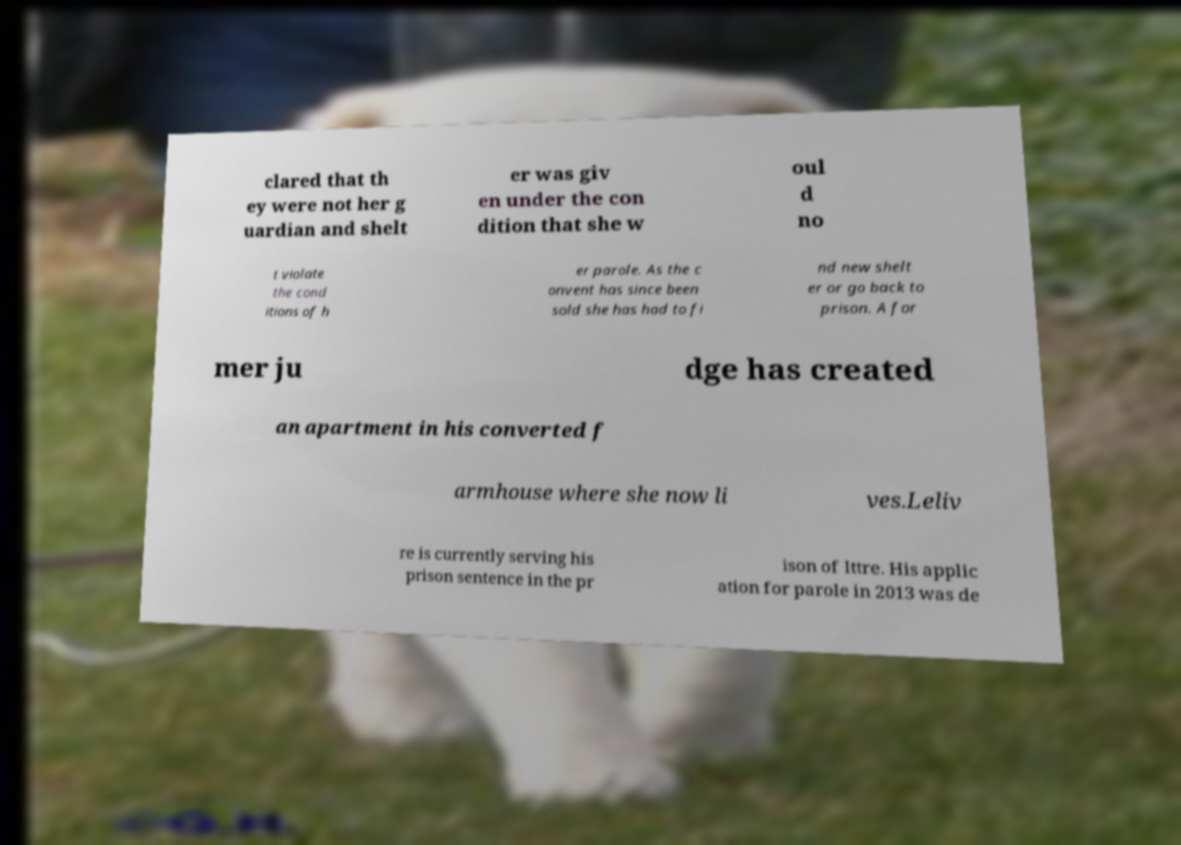Can you accurately transcribe the text from the provided image for me? clared that th ey were not her g uardian and shelt er was giv en under the con dition that she w oul d no t violate the cond itions of h er parole. As the c onvent has since been sold she has had to fi nd new shelt er or go back to prison. A for mer ju dge has created an apartment in his converted f armhouse where she now li ves.Leliv re is currently serving his prison sentence in the pr ison of Ittre. His applic ation for parole in 2013 was de 